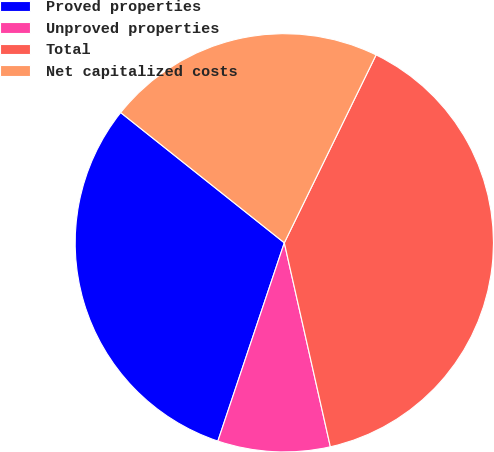<chart> <loc_0><loc_0><loc_500><loc_500><pie_chart><fcel>Proved properties<fcel>Unproved properties<fcel>Total<fcel>Net capitalized costs<nl><fcel>30.55%<fcel>8.68%<fcel>39.23%<fcel>21.53%<nl></chart> 